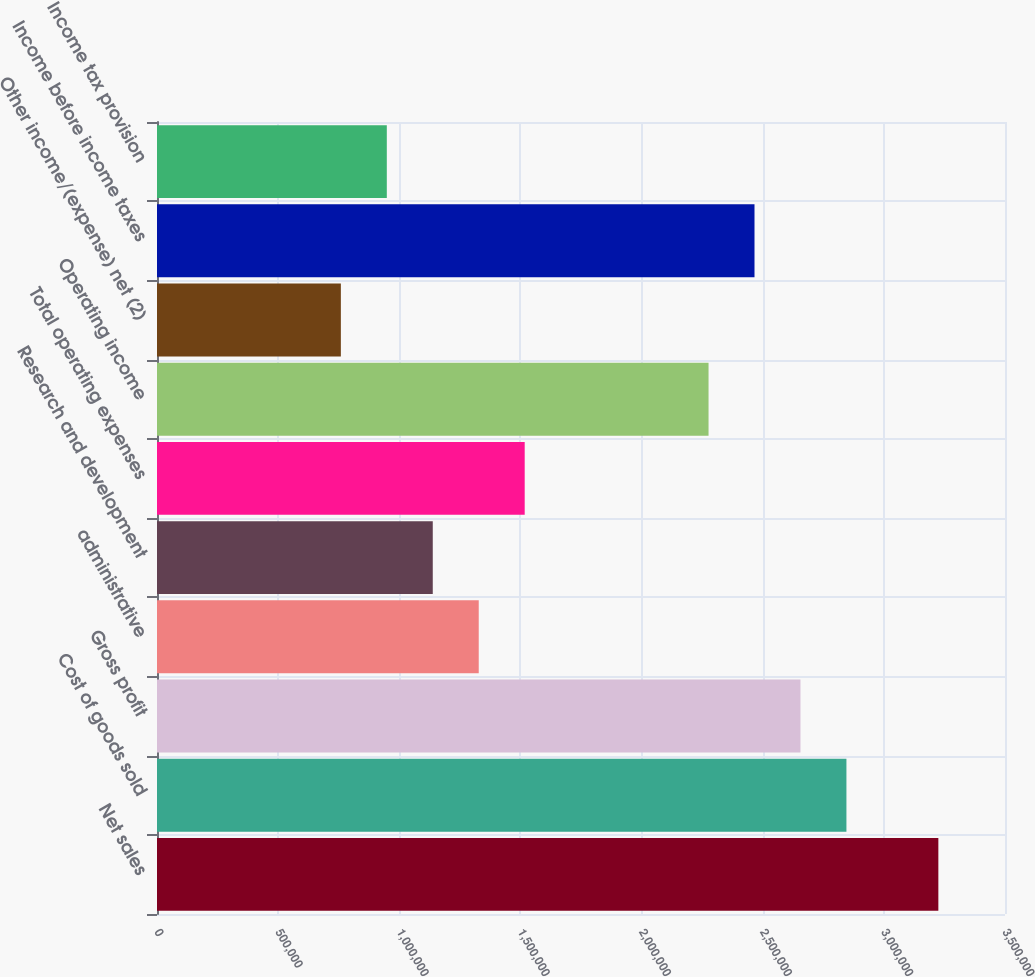<chart> <loc_0><loc_0><loc_500><loc_500><bar_chart><fcel>Net sales<fcel>Cost of goods sold<fcel>Gross profit<fcel>administrative<fcel>Research and development<fcel>Total operating expenses<fcel>Operating income<fcel>Other income/(expense) net (2)<fcel>Income before income taxes<fcel>Income tax provision<nl><fcel>3.22493e+06<fcel>2.84553e+06<fcel>2.65583e+06<fcel>1.32791e+06<fcel>1.13821e+06<fcel>1.51762e+06<fcel>2.27642e+06<fcel>758808<fcel>2.46613e+06<fcel>948510<nl></chart> 